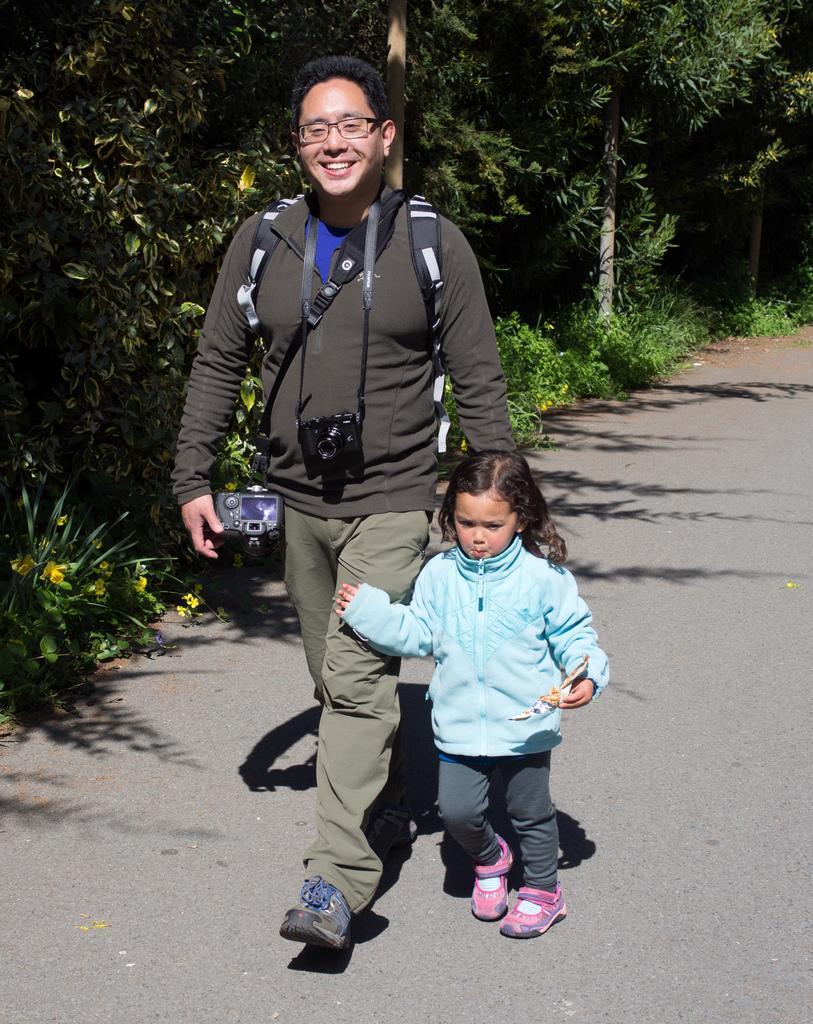Could you give a brief overview of what you see in this image? In this image I can see a person and a child walking on the road. Also there are trees, plants and there is grass. 